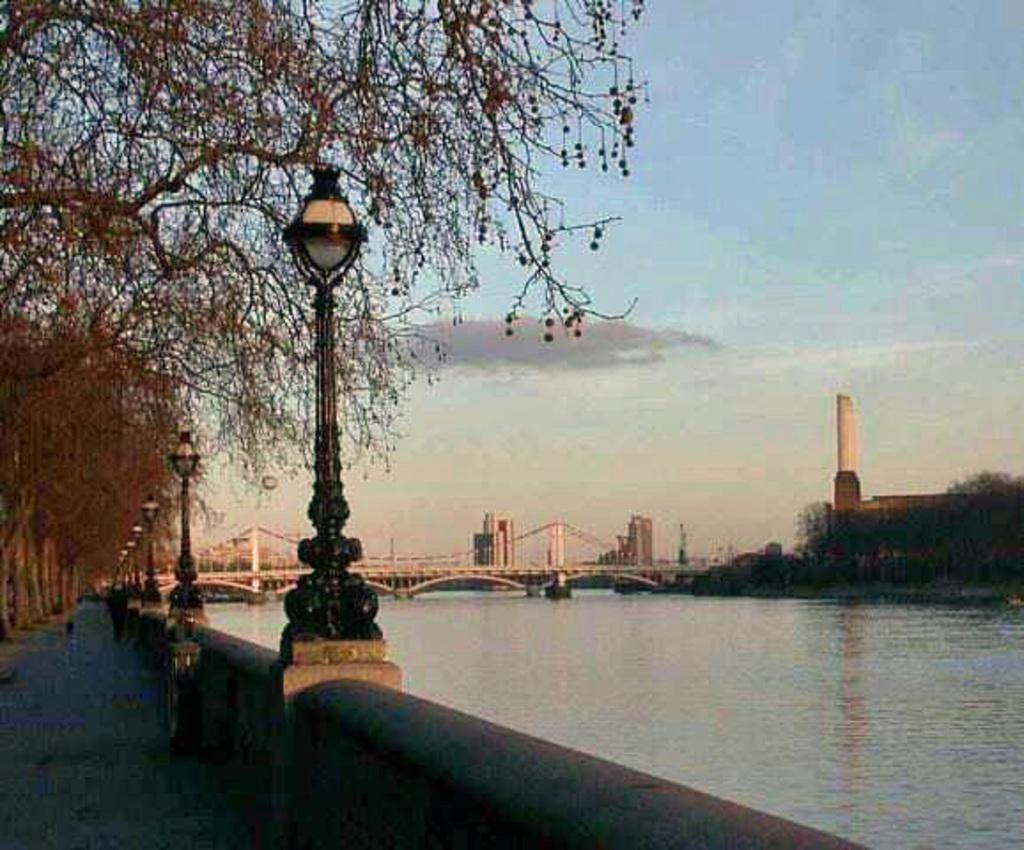Describe this image in one or two sentences. This image is taken outdoors. At the top of the image there is the sky with clouds. On the left side of the image there are many trees and there is a road. There is a fence and there are a few poles with street lights. On the right side of the image there is a river with water. There are a few trees and there are a few buildings. In the background there is a bridge with pillars and railings and there are a few buildings. 